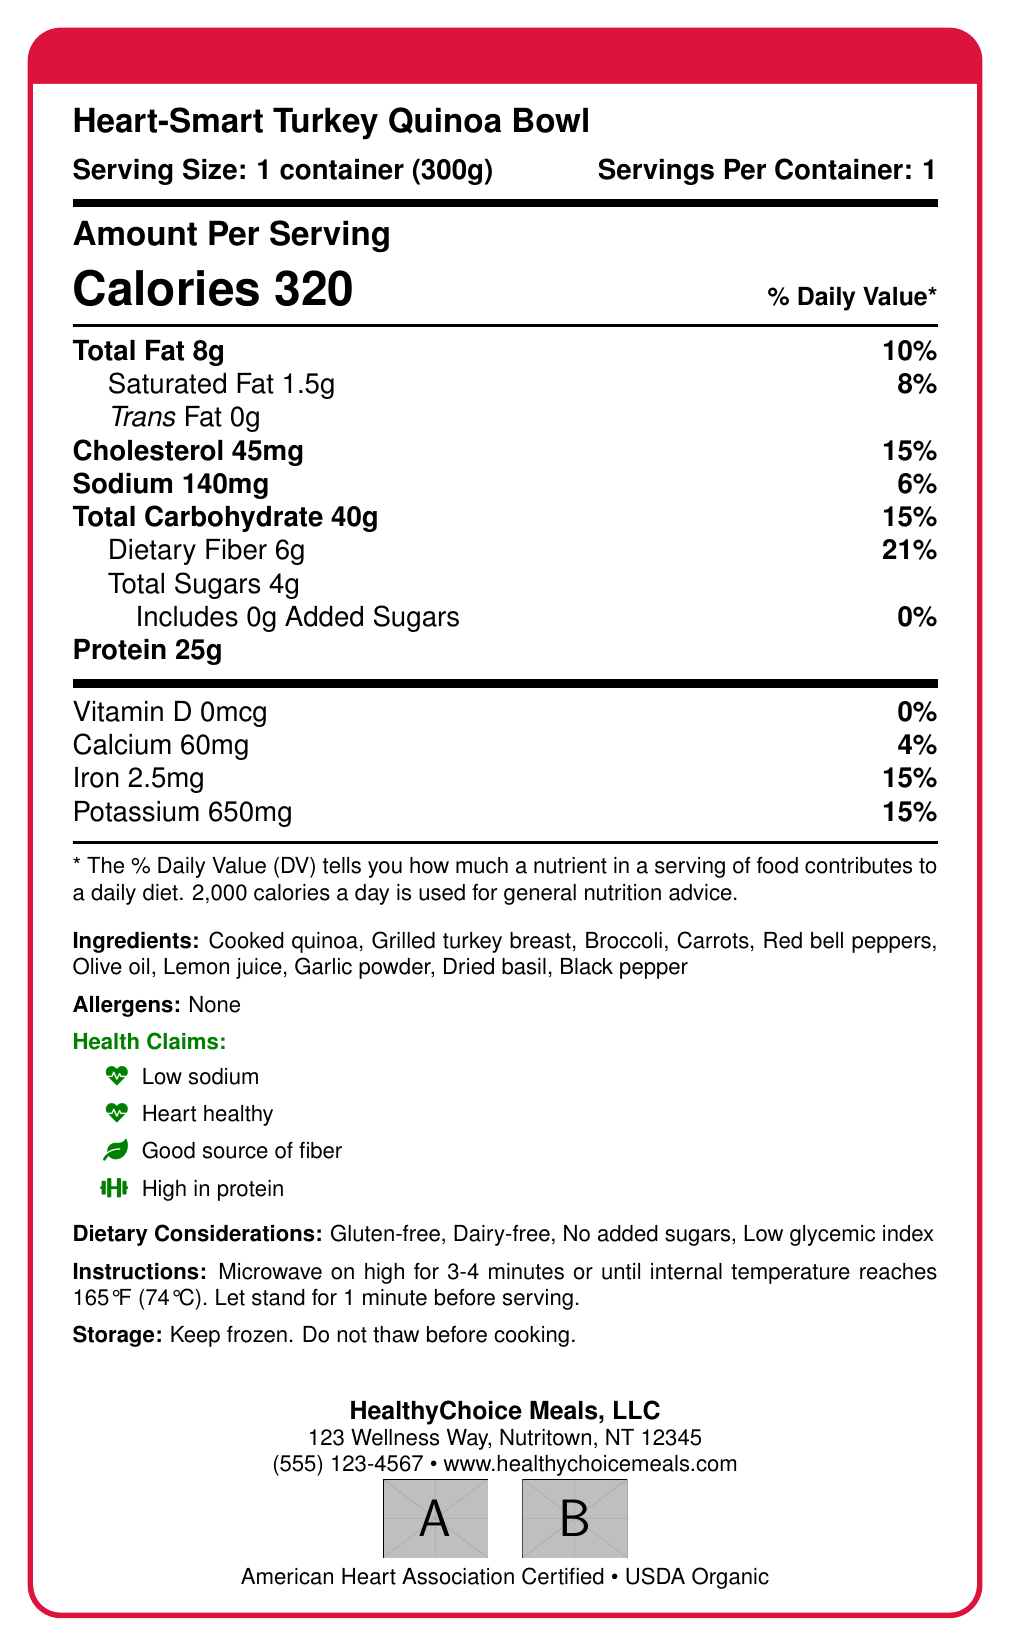what is the serving size? The document specifies the serving size directly under the product name.
Answer: 1 container (300g) how many calories are in one serving? The calorie content per serving is mentioned prominently in the document.
Answer: 320 what is the percentage daily value of dietary fiber? The document shows the daily value percentage next to the dietary fiber amount.
Answer: 21% which ingredient is listed first in the ingredients list? Ingredients are typically listed in descending order by weight, with Cooked quinoa being the first one listed.
Answer: Cooked quinoa how much potassium is in the meal? The amount of potassium is listed under the vitamins and minerals section.
Answer: 650 mg what is the sodium content per serving? The sodium content is listed clearly in the document.
Answer: 140 mg which of the following is not included in the health claims? A. Low sodium B. Low fat C. Heart healthy The health claims listed are low sodium, heart healthy, good source of fiber, and high in protein, but not low fat.
Answer: B. Low fat what percentage of daily value is the total fat content? A. 8% B. 10% C. 15% The document indicates that the total fat content is 10% of the daily value.
Answer: B. 10% does the document mention any allergens? The allergens section explicitly states "None".
Answer: No summarize the main idea of the document. The document is centered around presenting the nutritional facts, ingredients, health claims, dietary considerations, and company information for the Heart-Smart Turkey Quinoa Bowl, emphasizing its suitability for individuals with specific dietary needs.
Answer: The document provides nutritional information for the Heart-Smart Turkey Quinoa Bowl, highlighting its low sodium and heart-healthy attributes, along with ingredients, preparation instructions, and company details. does the product have any certifications? The document mentions that the product is American Heart Association Certified and USDA Organic.
Answer: Yes how long should the meal be microwaved? The preparation instructions specify that the meal should be microwaved for 3-4 minutes.
Answer: 3-4 minutes what is the address of the company? The company information includes the full address.
Answer: 123 Wellness Way, Nutritown, NT 12345 does the meal contain any added sugars? The document states that there are 0g of added sugars.
Answer: No what is the daily value percentage of calcium in the meal? The calcium content is listed along with its daily value percentage.
Answer: 4% what is the internal temperature the meal should reach after microwaving? The preparation instructions specify that the meal should reach an internal temperature of 165°F (74°C).
Answer: 165°F (74°C) what is the percentage daily value of iron in the meal? The document lists iron content with a daily value percentage of 15%.
Answer: 15% is this product gluten-free? The dietary considerations section lists gluten-free as one of the attributes.
Answer: Yes what is the exact address of the manufacturer? The document gives the address of HealthyChoice Meals, LLC but does not specify the actual manufacturing facility location.
Answer: Cannot be determined 